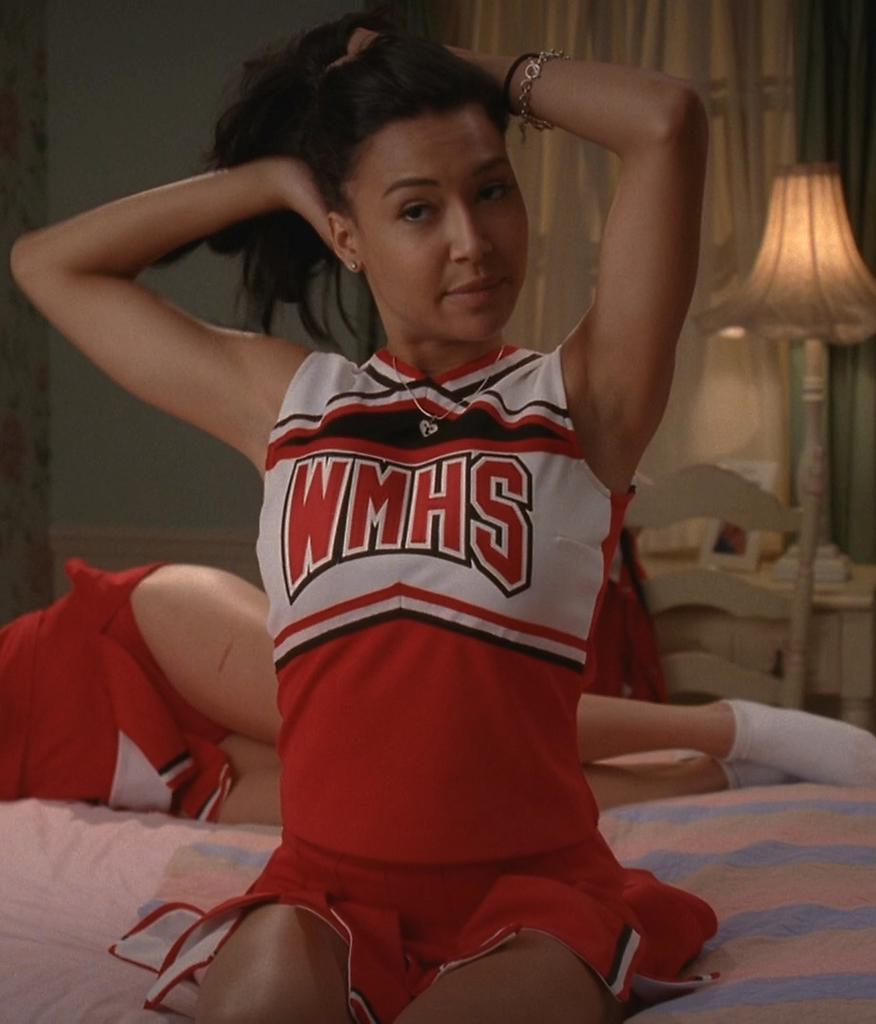<image>
Create a compact narrative representing the image presented. a cheerleader that is wearing a WMHS jersey 